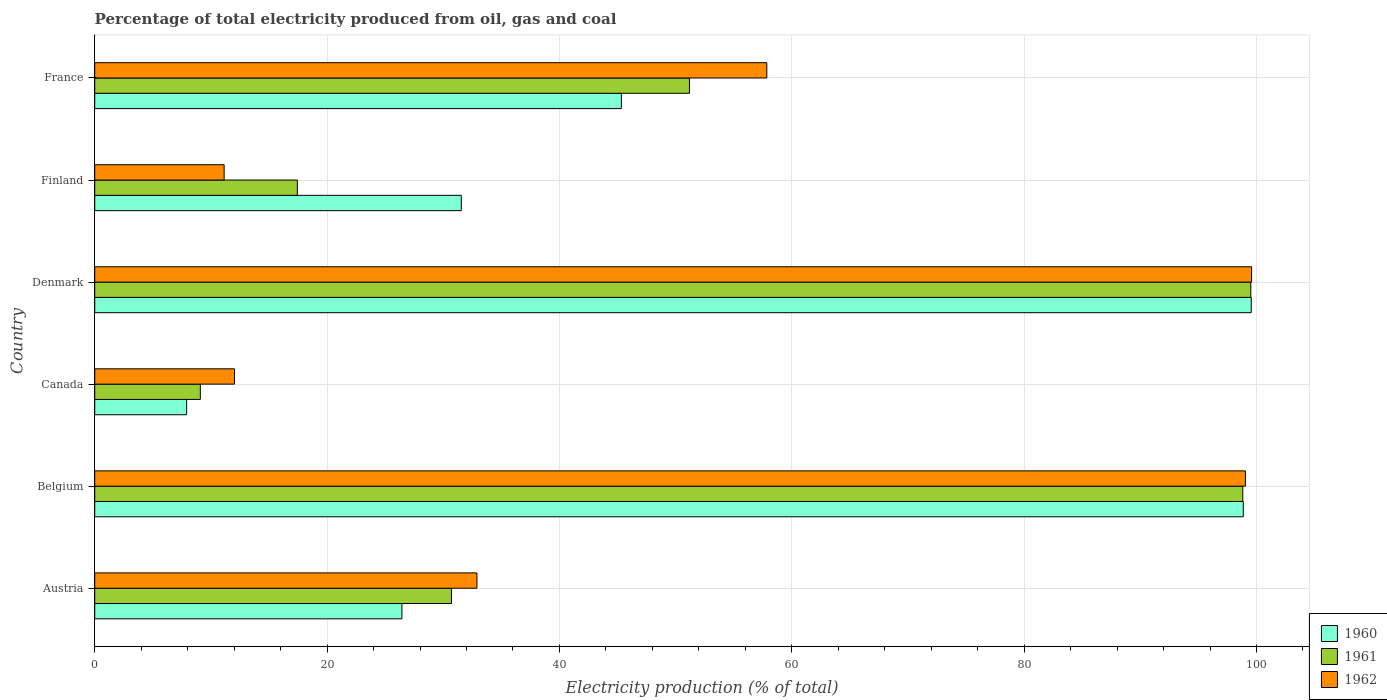How many different coloured bars are there?
Ensure brevity in your answer.  3. Are the number of bars per tick equal to the number of legend labels?
Provide a succinct answer. Yes. Are the number of bars on each tick of the Y-axis equal?
Your answer should be compact. Yes. How many bars are there on the 3rd tick from the bottom?
Offer a terse response. 3. What is the label of the 6th group of bars from the top?
Your answer should be compact. Austria. What is the electricity production in in 1961 in France?
Provide a succinct answer. 51.19. Across all countries, what is the maximum electricity production in in 1960?
Your answer should be very brief. 99.55. Across all countries, what is the minimum electricity production in in 1961?
Offer a terse response. 9.09. In which country was the electricity production in in 1961 minimum?
Your answer should be compact. Canada. What is the total electricity production in in 1960 in the graph?
Your answer should be very brief. 309.65. What is the difference between the electricity production in in 1962 in Denmark and that in Finland?
Keep it short and to the point. 88.44. What is the difference between the electricity production in in 1962 in Belgium and the electricity production in in 1960 in Austria?
Provide a short and direct response. 72.61. What is the average electricity production in in 1960 per country?
Keep it short and to the point. 51.61. What is the difference between the electricity production in in 1961 and electricity production in in 1962 in Canada?
Provide a succinct answer. -2.94. What is the ratio of the electricity production in in 1962 in Austria to that in Denmark?
Provide a short and direct response. 0.33. Is the electricity production in in 1962 in Belgium less than that in Canada?
Your answer should be compact. No. Is the difference between the electricity production in in 1961 in Austria and Denmark greater than the difference between the electricity production in in 1962 in Austria and Denmark?
Make the answer very short. No. What is the difference between the highest and the second highest electricity production in in 1962?
Offer a terse response. 0.53. What is the difference between the highest and the lowest electricity production in in 1960?
Provide a succinct answer. 91.64. In how many countries, is the electricity production in in 1961 greater than the average electricity production in in 1961 taken over all countries?
Your response must be concise. 3. Is the sum of the electricity production in in 1960 in Belgium and Canada greater than the maximum electricity production in in 1961 across all countries?
Give a very brief answer. Yes. What does the 3rd bar from the top in Finland represents?
Your response must be concise. 1960. How many countries are there in the graph?
Make the answer very short. 6. What is the difference between two consecutive major ticks on the X-axis?
Keep it short and to the point. 20. Are the values on the major ticks of X-axis written in scientific E-notation?
Offer a terse response. No. Does the graph contain any zero values?
Provide a succinct answer. No. Where does the legend appear in the graph?
Offer a terse response. Bottom right. How many legend labels are there?
Make the answer very short. 3. What is the title of the graph?
Give a very brief answer. Percentage of total electricity produced from oil, gas and coal. What is the label or title of the X-axis?
Keep it short and to the point. Electricity production (% of total). What is the label or title of the Y-axis?
Make the answer very short. Country. What is the Electricity production (% of total) in 1960 in Austria?
Give a very brief answer. 26.44. What is the Electricity production (% of total) of 1961 in Austria?
Ensure brevity in your answer.  30.71. What is the Electricity production (% of total) in 1962 in Austria?
Ensure brevity in your answer.  32.9. What is the Electricity production (% of total) in 1960 in Belgium?
Provide a succinct answer. 98.86. What is the Electricity production (% of total) of 1961 in Belgium?
Offer a very short reply. 98.82. What is the Electricity production (% of total) of 1962 in Belgium?
Make the answer very short. 99.05. What is the Electricity production (% of total) of 1960 in Canada?
Give a very brief answer. 7.91. What is the Electricity production (% of total) of 1961 in Canada?
Your response must be concise. 9.09. What is the Electricity production (% of total) in 1962 in Canada?
Offer a terse response. 12.03. What is the Electricity production (% of total) of 1960 in Denmark?
Offer a terse response. 99.55. What is the Electricity production (% of total) in 1961 in Denmark?
Give a very brief answer. 99.51. What is the Electricity production (% of total) of 1962 in Denmark?
Ensure brevity in your answer.  99.58. What is the Electricity production (% of total) in 1960 in Finland?
Your answer should be very brief. 31.55. What is the Electricity production (% of total) of 1961 in Finland?
Provide a short and direct response. 17.44. What is the Electricity production (% of total) of 1962 in Finland?
Your answer should be compact. 11.14. What is the Electricity production (% of total) in 1960 in France?
Ensure brevity in your answer.  45.33. What is the Electricity production (% of total) of 1961 in France?
Ensure brevity in your answer.  51.19. What is the Electricity production (% of total) in 1962 in France?
Keep it short and to the point. 57.85. Across all countries, what is the maximum Electricity production (% of total) of 1960?
Your answer should be compact. 99.55. Across all countries, what is the maximum Electricity production (% of total) in 1961?
Your response must be concise. 99.51. Across all countries, what is the maximum Electricity production (% of total) in 1962?
Make the answer very short. 99.58. Across all countries, what is the minimum Electricity production (% of total) of 1960?
Offer a terse response. 7.91. Across all countries, what is the minimum Electricity production (% of total) of 1961?
Your answer should be very brief. 9.09. Across all countries, what is the minimum Electricity production (% of total) of 1962?
Ensure brevity in your answer.  11.14. What is the total Electricity production (% of total) of 1960 in the graph?
Offer a terse response. 309.65. What is the total Electricity production (% of total) of 1961 in the graph?
Provide a succinct answer. 306.76. What is the total Electricity production (% of total) of 1962 in the graph?
Provide a succinct answer. 312.55. What is the difference between the Electricity production (% of total) of 1960 in Austria and that in Belgium?
Offer a terse response. -72.42. What is the difference between the Electricity production (% of total) in 1961 in Austria and that in Belgium?
Give a very brief answer. -68.11. What is the difference between the Electricity production (% of total) of 1962 in Austria and that in Belgium?
Keep it short and to the point. -66.15. What is the difference between the Electricity production (% of total) of 1960 in Austria and that in Canada?
Offer a very short reply. 18.53. What is the difference between the Electricity production (% of total) of 1961 in Austria and that in Canada?
Your answer should be compact. 21.62. What is the difference between the Electricity production (% of total) in 1962 in Austria and that in Canada?
Ensure brevity in your answer.  20.87. What is the difference between the Electricity production (% of total) in 1960 in Austria and that in Denmark?
Provide a succinct answer. -73.11. What is the difference between the Electricity production (% of total) of 1961 in Austria and that in Denmark?
Your answer should be compact. -68.8. What is the difference between the Electricity production (% of total) of 1962 in Austria and that in Denmark?
Your answer should be very brief. -66.68. What is the difference between the Electricity production (% of total) of 1960 in Austria and that in Finland?
Your answer should be very brief. -5.11. What is the difference between the Electricity production (% of total) of 1961 in Austria and that in Finland?
Your answer should be very brief. 13.27. What is the difference between the Electricity production (% of total) of 1962 in Austria and that in Finland?
Your response must be concise. 21.76. What is the difference between the Electricity production (% of total) in 1960 in Austria and that in France?
Ensure brevity in your answer.  -18.89. What is the difference between the Electricity production (% of total) in 1961 in Austria and that in France?
Your answer should be very brief. -20.49. What is the difference between the Electricity production (% of total) in 1962 in Austria and that in France?
Offer a terse response. -24.95. What is the difference between the Electricity production (% of total) in 1960 in Belgium and that in Canada?
Your answer should be compact. 90.95. What is the difference between the Electricity production (% of total) in 1961 in Belgium and that in Canada?
Make the answer very short. 89.73. What is the difference between the Electricity production (% of total) in 1962 in Belgium and that in Canada?
Give a very brief answer. 87.02. What is the difference between the Electricity production (% of total) in 1960 in Belgium and that in Denmark?
Ensure brevity in your answer.  -0.68. What is the difference between the Electricity production (% of total) in 1961 in Belgium and that in Denmark?
Offer a very short reply. -0.69. What is the difference between the Electricity production (% of total) in 1962 in Belgium and that in Denmark?
Your answer should be compact. -0.53. What is the difference between the Electricity production (% of total) of 1960 in Belgium and that in Finland?
Your answer should be very brief. 67.31. What is the difference between the Electricity production (% of total) of 1961 in Belgium and that in Finland?
Keep it short and to the point. 81.38. What is the difference between the Electricity production (% of total) in 1962 in Belgium and that in Finland?
Your response must be concise. 87.91. What is the difference between the Electricity production (% of total) in 1960 in Belgium and that in France?
Offer a very short reply. 53.53. What is the difference between the Electricity production (% of total) of 1961 in Belgium and that in France?
Your answer should be compact. 47.63. What is the difference between the Electricity production (% of total) in 1962 in Belgium and that in France?
Your answer should be compact. 41.2. What is the difference between the Electricity production (% of total) of 1960 in Canada and that in Denmark?
Make the answer very short. -91.64. What is the difference between the Electricity production (% of total) of 1961 in Canada and that in Denmark?
Your answer should be compact. -90.42. What is the difference between the Electricity production (% of total) of 1962 in Canada and that in Denmark?
Offer a terse response. -87.55. What is the difference between the Electricity production (% of total) of 1960 in Canada and that in Finland?
Provide a short and direct response. -23.64. What is the difference between the Electricity production (% of total) in 1961 in Canada and that in Finland?
Keep it short and to the point. -8.35. What is the difference between the Electricity production (% of total) in 1962 in Canada and that in Finland?
Ensure brevity in your answer.  0.89. What is the difference between the Electricity production (% of total) of 1960 in Canada and that in France?
Give a very brief answer. -37.42. What is the difference between the Electricity production (% of total) of 1961 in Canada and that in France?
Keep it short and to the point. -42.1. What is the difference between the Electricity production (% of total) in 1962 in Canada and that in France?
Your answer should be compact. -45.82. What is the difference between the Electricity production (% of total) of 1960 in Denmark and that in Finland?
Ensure brevity in your answer.  68. What is the difference between the Electricity production (% of total) in 1961 in Denmark and that in Finland?
Offer a very short reply. 82.07. What is the difference between the Electricity production (% of total) in 1962 in Denmark and that in Finland?
Give a very brief answer. 88.44. What is the difference between the Electricity production (% of total) in 1960 in Denmark and that in France?
Give a very brief answer. 54.22. What is the difference between the Electricity production (% of total) of 1961 in Denmark and that in France?
Make the answer very short. 48.32. What is the difference between the Electricity production (% of total) in 1962 in Denmark and that in France?
Ensure brevity in your answer.  41.73. What is the difference between the Electricity production (% of total) of 1960 in Finland and that in France?
Keep it short and to the point. -13.78. What is the difference between the Electricity production (% of total) in 1961 in Finland and that in France?
Provide a short and direct response. -33.75. What is the difference between the Electricity production (% of total) of 1962 in Finland and that in France?
Give a very brief answer. -46.71. What is the difference between the Electricity production (% of total) in 1960 in Austria and the Electricity production (% of total) in 1961 in Belgium?
Your answer should be compact. -72.38. What is the difference between the Electricity production (% of total) in 1960 in Austria and the Electricity production (% of total) in 1962 in Belgium?
Give a very brief answer. -72.61. What is the difference between the Electricity production (% of total) of 1961 in Austria and the Electricity production (% of total) of 1962 in Belgium?
Offer a terse response. -68.34. What is the difference between the Electricity production (% of total) of 1960 in Austria and the Electricity production (% of total) of 1961 in Canada?
Provide a succinct answer. 17.35. What is the difference between the Electricity production (% of total) of 1960 in Austria and the Electricity production (% of total) of 1962 in Canada?
Offer a terse response. 14.41. What is the difference between the Electricity production (% of total) in 1961 in Austria and the Electricity production (% of total) in 1962 in Canada?
Make the answer very short. 18.67. What is the difference between the Electricity production (% of total) in 1960 in Austria and the Electricity production (% of total) in 1961 in Denmark?
Keep it short and to the point. -73.07. What is the difference between the Electricity production (% of total) of 1960 in Austria and the Electricity production (% of total) of 1962 in Denmark?
Provide a short and direct response. -73.14. What is the difference between the Electricity production (% of total) of 1961 in Austria and the Electricity production (% of total) of 1962 in Denmark?
Your answer should be very brief. -68.87. What is the difference between the Electricity production (% of total) of 1960 in Austria and the Electricity production (% of total) of 1961 in Finland?
Make the answer very short. 9. What is the difference between the Electricity production (% of total) of 1960 in Austria and the Electricity production (% of total) of 1962 in Finland?
Provide a short and direct response. 15.3. What is the difference between the Electricity production (% of total) in 1961 in Austria and the Electricity production (% of total) in 1962 in Finland?
Your response must be concise. 19.57. What is the difference between the Electricity production (% of total) in 1960 in Austria and the Electricity production (% of total) in 1961 in France?
Keep it short and to the point. -24.75. What is the difference between the Electricity production (% of total) in 1960 in Austria and the Electricity production (% of total) in 1962 in France?
Your answer should be compact. -31.41. What is the difference between the Electricity production (% of total) of 1961 in Austria and the Electricity production (% of total) of 1962 in France?
Make the answer very short. -27.15. What is the difference between the Electricity production (% of total) of 1960 in Belgium and the Electricity production (% of total) of 1961 in Canada?
Provide a succinct answer. 89.78. What is the difference between the Electricity production (% of total) of 1960 in Belgium and the Electricity production (% of total) of 1962 in Canada?
Offer a very short reply. 86.83. What is the difference between the Electricity production (% of total) of 1961 in Belgium and the Electricity production (% of total) of 1962 in Canada?
Offer a terse response. 86.79. What is the difference between the Electricity production (% of total) of 1960 in Belgium and the Electricity production (% of total) of 1961 in Denmark?
Your answer should be compact. -0.65. What is the difference between the Electricity production (% of total) of 1960 in Belgium and the Electricity production (% of total) of 1962 in Denmark?
Offer a very short reply. -0.71. What is the difference between the Electricity production (% of total) of 1961 in Belgium and the Electricity production (% of total) of 1962 in Denmark?
Make the answer very short. -0.76. What is the difference between the Electricity production (% of total) in 1960 in Belgium and the Electricity production (% of total) in 1961 in Finland?
Ensure brevity in your answer.  81.42. What is the difference between the Electricity production (% of total) in 1960 in Belgium and the Electricity production (% of total) in 1962 in Finland?
Your response must be concise. 87.72. What is the difference between the Electricity production (% of total) of 1961 in Belgium and the Electricity production (% of total) of 1962 in Finland?
Provide a succinct answer. 87.68. What is the difference between the Electricity production (% of total) of 1960 in Belgium and the Electricity production (% of total) of 1961 in France?
Ensure brevity in your answer.  47.67. What is the difference between the Electricity production (% of total) of 1960 in Belgium and the Electricity production (% of total) of 1962 in France?
Your answer should be very brief. 41.01. What is the difference between the Electricity production (% of total) in 1961 in Belgium and the Electricity production (% of total) in 1962 in France?
Keep it short and to the point. 40.97. What is the difference between the Electricity production (% of total) in 1960 in Canada and the Electricity production (% of total) in 1961 in Denmark?
Ensure brevity in your answer.  -91.6. What is the difference between the Electricity production (% of total) of 1960 in Canada and the Electricity production (% of total) of 1962 in Denmark?
Keep it short and to the point. -91.67. What is the difference between the Electricity production (% of total) in 1961 in Canada and the Electricity production (% of total) in 1962 in Denmark?
Keep it short and to the point. -90.49. What is the difference between the Electricity production (% of total) in 1960 in Canada and the Electricity production (% of total) in 1961 in Finland?
Provide a short and direct response. -9.53. What is the difference between the Electricity production (% of total) of 1960 in Canada and the Electricity production (% of total) of 1962 in Finland?
Ensure brevity in your answer.  -3.23. What is the difference between the Electricity production (% of total) in 1961 in Canada and the Electricity production (% of total) in 1962 in Finland?
Offer a very short reply. -2.05. What is the difference between the Electricity production (% of total) in 1960 in Canada and the Electricity production (% of total) in 1961 in France?
Your answer should be very brief. -43.28. What is the difference between the Electricity production (% of total) of 1960 in Canada and the Electricity production (% of total) of 1962 in France?
Offer a very short reply. -49.94. What is the difference between the Electricity production (% of total) of 1961 in Canada and the Electricity production (% of total) of 1962 in France?
Give a very brief answer. -48.76. What is the difference between the Electricity production (% of total) in 1960 in Denmark and the Electricity production (% of total) in 1961 in Finland?
Keep it short and to the point. 82.11. What is the difference between the Electricity production (% of total) of 1960 in Denmark and the Electricity production (% of total) of 1962 in Finland?
Your answer should be compact. 88.41. What is the difference between the Electricity production (% of total) in 1961 in Denmark and the Electricity production (% of total) in 1962 in Finland?
Offer a terse response. 88.37. What is the difference between the Electricity production (% of total) of 1960 in Denmark and the Electricity production (% of total) of 1961 in France?
Your response must be concise. 48.36. What is the difference between the Electricity production (% of total) of 1960 in Denmark and the Electricity production (% of total) of 1962 in France?
Your response must be concise. 41.7. What is the difference between the Electricity production (% of total) of 1961 in Denmark and the Electricity production (% of total) of 1962 in France?
Keep it short and to the point. 41.66. What is the difference between the Electricity production (% of total) in 1960 in Finland and the Electricity production (% of total) in 1961 in France?
Keep it short and to the point. -19.64. What is the difference between the Electricity production (% of total) in 1960 in Finland and the Electricity production (% of total) in 1962 in France?
Your answer should be compact. -26.3. What is the difference between the Electricity production (% of total) in 1961 in Finland and the Electricity production (% of total) in 1962 in France?
Ensure brevity in your answer.  -40.41. What is the average Electricity production (% of total) of 1960 per country?
Give a very brief answer. 51.61. What is the average Electricity production (% of total) of 1961 per country?
Offer a very short reply. 51.13. What is the average Electricity production (% of total) of 1962 per country?
Your answer should be compact. 52.09. What is the difference between the Electricity production (% of total) of 1960 and Electricity production (% of total) of 1961 in Austria?
Make the answer very short. -4.27. What is the difference between the Electricity production (% of total) in 1960 and Electricity production (% of total) in 1962 in Austria?
Make the answer very short. -6.46. What is the difference between the Electricity production (% of total) in 1961 and Electricity production (% of total) in 1962 in Austria?
Ensure brevity in your answer.  -2.19. What is the difference between the Electricity production (% of total) in 1960 and Electricity production (% of total) in 1961 in Belgium?
Offer a very short reply. 0.04. What is the difference between the Electricity production (% of total) of 1960 and Electricity production (% of total) of 1962 in Belgium?
Offer a very short reply. -0.18. What is the difference between the Electricity production (% of total) of 1961 and Electricity production (% of total) of 1962 in Belgium?
Your response must be concise. -0.23. What is the difference between the Electricity production (% of total) of 1960 and Electricity production (% of total) of 1961 in Canada?
Provide a short and direct response. -1.18. What is the difference between the Electricity production (% of total) in 1960 and Electricity production (% of total) in 1962 in Canada?
Your answer should be compact. -4.12. What is the difference between the Electricity production (% of total) of 1961 and Electricity production (% of total) of 1962 in Canada?
Make the answer very short. -2.94. What is the difference between the Electricity production (% of total) of 1960 and Electricity production (% of total) of 1961 in Denmark?
Ensure brevity in your answer.  0.04. What is the difference between the Electricity production (% of total) of 1960 and Electricity production (% of total) of 1962 in Denmark?
Offer a very short reply. -0.03. What is the difference between the Electricity production (% of total) of 1961 and Electricity production (% of total) of 1962 in Denmark?
Your answer should be compact. -0.07. What is the difference between the Electricity production (% of total) in 1960 and Electricity production (% of total) in 1961 in Finland?
Your answer should be very brief. 14.11. What is the difference between the Electricity production (% of total) in 1960 and Electricity production (% of total) in 1962 in Finland?
Give a very brief answer. 20.41. What is the difference between the Electricity production (% of total) in 1961 and Electricity production (% of total) in 1962 in Finland?
Keep it short and to the point. 6.3. What is the difference between the Electricity production (% of total) in 1960 and Electricity production (% of total) in 1961 in France?
Offer a very short reply. -5.86. What is the difference between the Electricity production (% of total) in 1960 and Electricity production (% of total) in 1962 in France?
Make the answer very short. -12.52. What is the difference between the Electricity production (% of total) in 1961 and Electricity production (% of total) in 1962 in France?
Your response must be concise. -6.66. What is the ratio of the Electricity production (% of total) in 1960 in Austria to that in Belgium?
Provide a short and direct response. 0.27. What is the ratio of the Electricity production (% of total) of 1961 in Austria to that in Belgium?
Keep it short and to the point. 0.31. What is the ratio of the Electricity production (% of total) of 1962 in Austria to that in Belgium?
Make the answer very short. 0.33. What is the ratio of the Electricity production (% of total) of 1960 in Austria to that in Canada?
Your response must be concise. 3.34. What is the ratio of the Electricity production (% of total) of 1961 in Austria to that in Canada?
Make the answer very short. 3.38. What is the ratio of the Electricity production (% of total) in 1962 in Austria to that in Canada?
Keep it short and to the point. 2.73. What is the ratio of the Electricity production (% of total) of 1960 in Austria to that in Denmark?
Offer a very short reply. 0.27. What is the ratio of the Electricity production (% of total) in 1961 in Austria to that in Denmark?
Offer a very short reply. 0.31. What is the ratio of the Electricity production (% of total) of 1962 in Austria to that in Denmark?
Ensure brevity in your answer.  0.33. What is the ratio of the Electricity production (% of total) in 1960 in Austria to that in Finland?
Keep it short and to the point. 0.84. What is the ratio of the Electricity production (% of total) in 1961 in Austria to that in Finland?
Your response must be concise. 1.76. What is the ratio of the Electricity production (% of total) of 1962 in Austria to that in Finland?
Provide a short and direct response. 2.95. What is the ratio of the Electricity production (% of total) in 1960 in Austria to that in France?
Offer a very short reply. 0.58. What is the ratio of the Electricity production (% of total) of 1961 in Austria to that in France?
Offer a terse response. 0.6. What is the ratio of the Electricity production (% of total) in 1962 in Austria to that in France?
Give a very brief answer. 0.57. What is the ratio of the Electricity production (% of total) of 1960 in Belgium to that in Canada?
Provide a succinct answer. 12.5. What is the ratio of the Electricity production (% of total) in 1961 in Belgium to that in Canada?
Keep it short and to the point. 10.87. What is the ratio of the Electricity production (% of total) of 1962 in Belgium to that in Canada?
Provide a short and direct response. 8.23. What is the ratio of the Electricity production (% of total) in 1961 in Belgium to that in Denmark?
Keep it short and to the point. 0.99. What is the ratio of the Electricity production (% of total) of 1962 in Belgium to that in Denmark?
Keep it short and to the point. 0.99. What is the ratio of the Electricity production (% of total) in 1960 in Belgium to that in Finland?
Provide a short and direct response. 3.13. What is the ratio of the Electricity production (% of total) of 1961 in Belgium to that in Finland?
Offer a terse response. 5.67. What is the ratio of the Electricity production (% of total) of 1962 in Belgium to that in Finland?
Offer a very short reply. 8.89. What is the ratio of the Electricity production (% of total) in 1960 in Belgium to that in France?
Provide a short and direct response. 2.18. What is the ratio of the Electricity production (% of total) in 1961 in Belgium to that in France?
Make the answer very short. 1.93. What is the ratio of the Electricity production (% of total) in 1962 in Belgium to that in France?
Provide a succinct answer. 1.71. What is the ratio of the Electricity production (% of total) in 1960 in Canada to that in Denmark?
Offer a terse response. 0.08. What is the ratio of the Electricity production (% of total) in 1961 in Canada to that in Denmark?
Keep it short and to the point. 0.09. What is the ratio of the Electricity production (% of total) in 1962 in Canada to that in Denmark?
Ensure brevity in your answer.  0.12. What is the ratio of the Electricity production (% of total) of 1960 in Canada to that in Finland?
Offer a very short reply. 0.25. What is the ratio of the Electricity production (% of total) of 1961 in Canada to that in Finland?
Your answer should be very brief. 0.52. What is the ratio of the Electricity production (% of total) in 1960 in Canada to that in France?
Your answer should be compact. 0.17. What is the ratio of the Electricity production (% of total) in 1961 in Canada to that in France?
Keep it short and to the point. 0.18. What is the ratio of the Electricity production (% of total) of 1962 in Canada to that in France?
Provide a short and direct response. 0.21. What is the ratio of the Electricity production (% of total) in 1960 in Denmark to that in Finland?
Provide a succinct answer. 3.16. What is the ratio of the Electricity production (% of total) in 1961 in Denmark to that in Finland?
Offer a very short reply. 5.71. What is the ratio of the Electricity production (% of total) in 1962 in Denmark to that in Finland?
Make the answer very short. 8.94. What is the ratio of the Electricity production (% of total) in 1960 in Denmark to that in France?
Ensure brevity in your answer.  2.2. What is the ratio of the Electricity production (% of total) in 1961 in Denmark to that in France?
Give a very brief answer. 1.94. What is the ratio of the Electricity production (% of total) of 1962 in Denmark to that in France?
Keep it short and to the point. 1.72. What is the ratio of the Electricity production (% of total) of 1960 in Finland to that in France?
Offer a very short reply. 0.7. What is the ratio of the Electricity production (% of total) in 1961 in Finland to that in France?
Your response must be concise. 0.34. What is the ratio of the Electricity production (% of total) of 1962 in Finland to that in France?
Keep it short and to the point. 0.19. What is the difference between the highest and the second highest Electricity production (% of total) of 1960?
Your answer should be very brief. 0.68. What is the difference between the highest and the second highest Electricity production (% of total) in 1961?
Give a very brief answer. 0.69. What is the difference between the highest and the second highest Electricity production (% of total) in 1962?
Your answer should be very brief. 0.53. What is the difference between the highest and the lowest Electricity production (% of total) of 1960?
Offer a terse response. 91.64. What is the difference between the highest and the lowest Electricity production (% of total) of 1961?
Provide a succinct answer. 90.42. What is the difference between the highest and the lowest Electricity production (% of total) in 1962?
Make the answer very short. 88.44. 